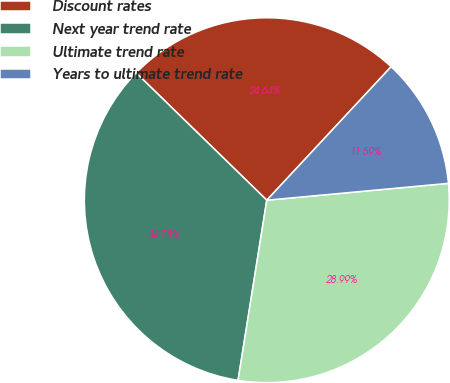Convert chart to OTSL. <chart><loc_0><loc_0><loc_500><loc_500><pie_chart><fcel>Discount rates<fcel>Next year trend rate<fcel>Ultimate trend rate<fcel>Years to ultimate trend rate<nl><fcel>24.64%<fcel>34.78%<fcel>28.99%<fcel>11.59%<nl></chart> 